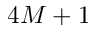<formula> <loc_0><loc_0><loc_500><loc_500>4 M + 1</formula> 